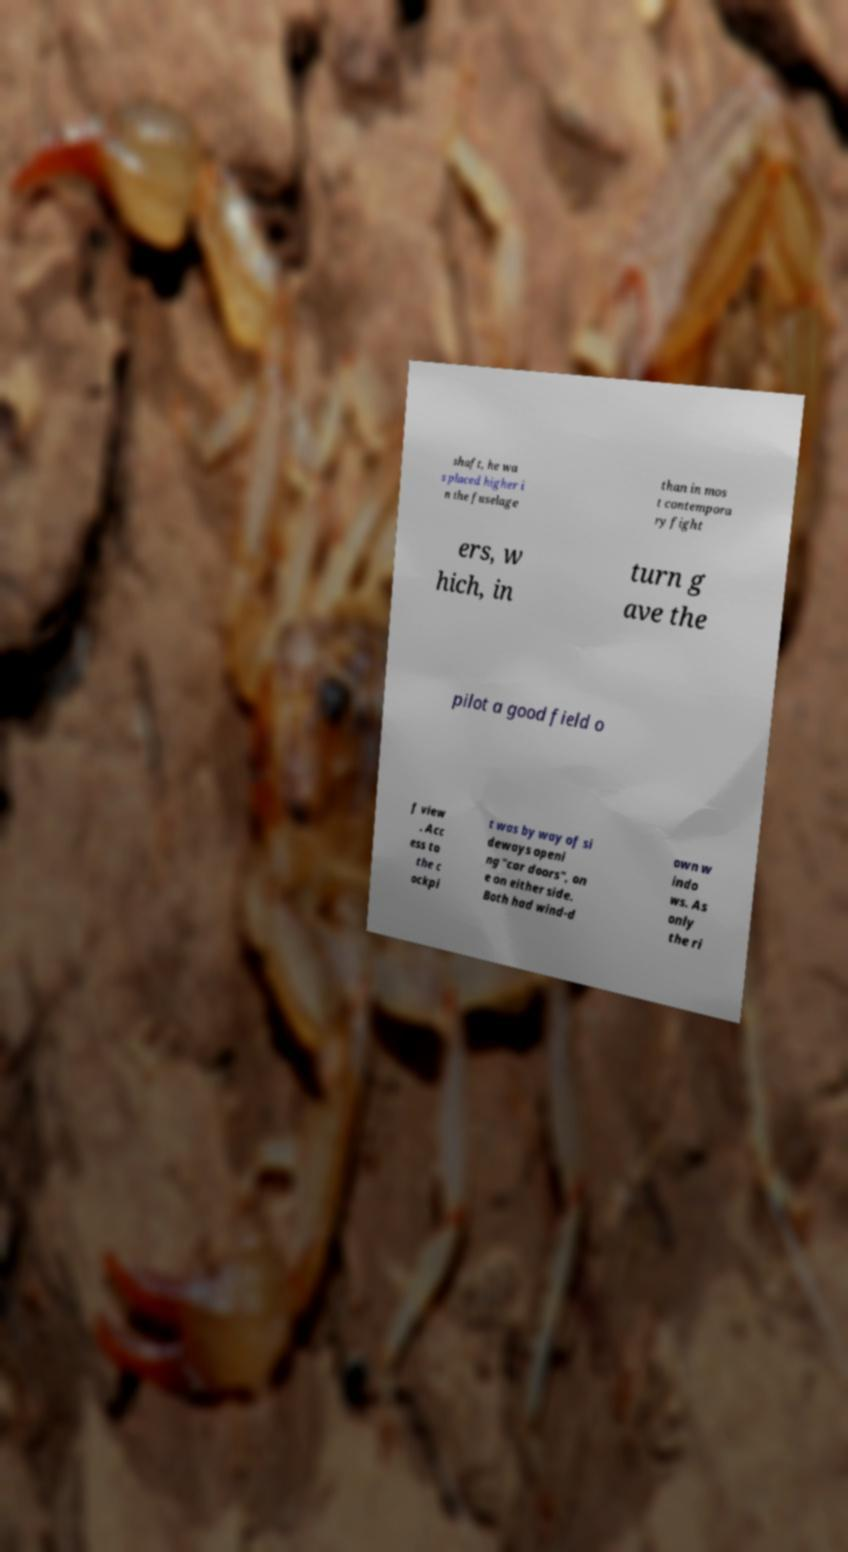Can you accurately transcribe the text from the provided image for me? shaft, he wa s placed higher i n the fuselage than in mos t contempora ry fight ers, w hich, in turn g ave the pilot a good field o f view . Acc ess to the c ockpi t was by way of si deways openi ng "car doors", on e on either side. Both had wind-d own w indo ws. As only the ri 